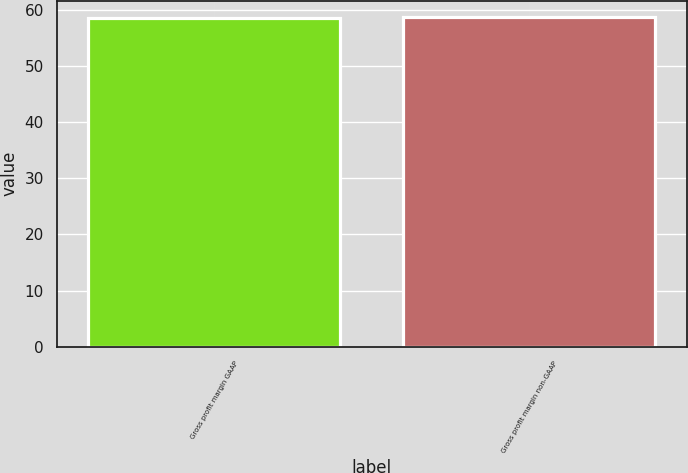Convert chart to OTSL. <chart><loc_0><loc_0><loc_500><loc_500><bar_chart><fcel>Gross profit margin GAAP<fcel>Gross profit margin non-GAAP<nl><fcel>58.5<fcel>58.7<nl></chart> 